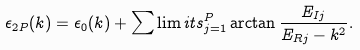Convert formula to latex. <formula><loc_0><loc_0><loc_500><loc_500>\epsilon _ { 2 P } ( k ) = \epsilon _ { 0 } ( k ) + \sum \lim i t s _ { j = 1 } ^ { P } \arctan \frac { E _ { I j } } { E _ { R j } - k ^ { 2 } } .</formula> 